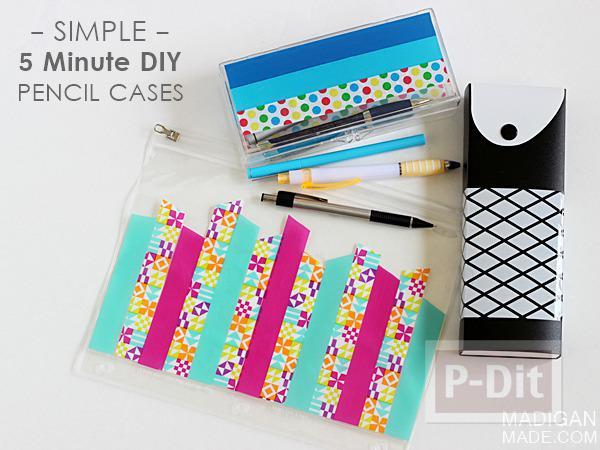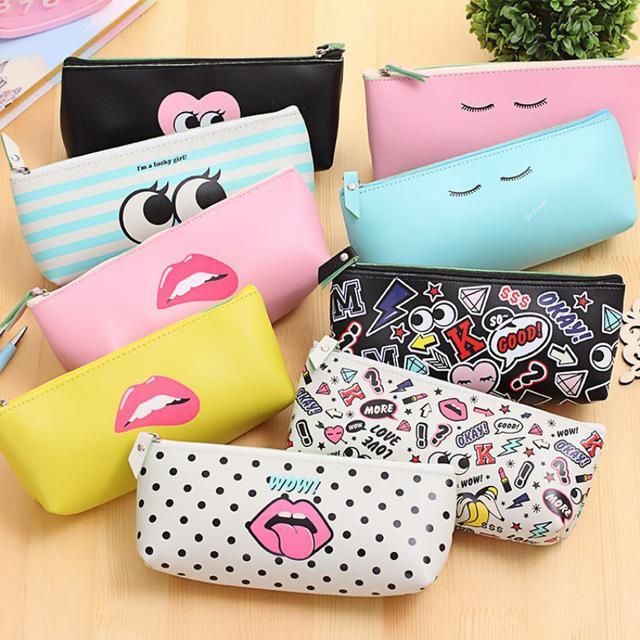The first image is the image on the left, the second image is the image on the right. For the images shown, is this caption "Multiple writing implements are shown with pencil cases in each image." true? Answer yes or no. No. The first image is the image on the left, the second image is the image on the right. Evaluate the accuracy of this statement regarding the images: "The left image contain a single pencil case that is predominantly pink.". Is it true? Answer yes or no. No. 